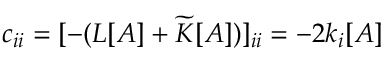Convert formula to latex. <formula><loc_0><loc_0><loc_500><loc_500>c _ { i i } = [ - ( L [ A ] + \widetilde { K } [ A ] ) ] _ { i i } = - 2 k _ { i } [ A ]</formula> 